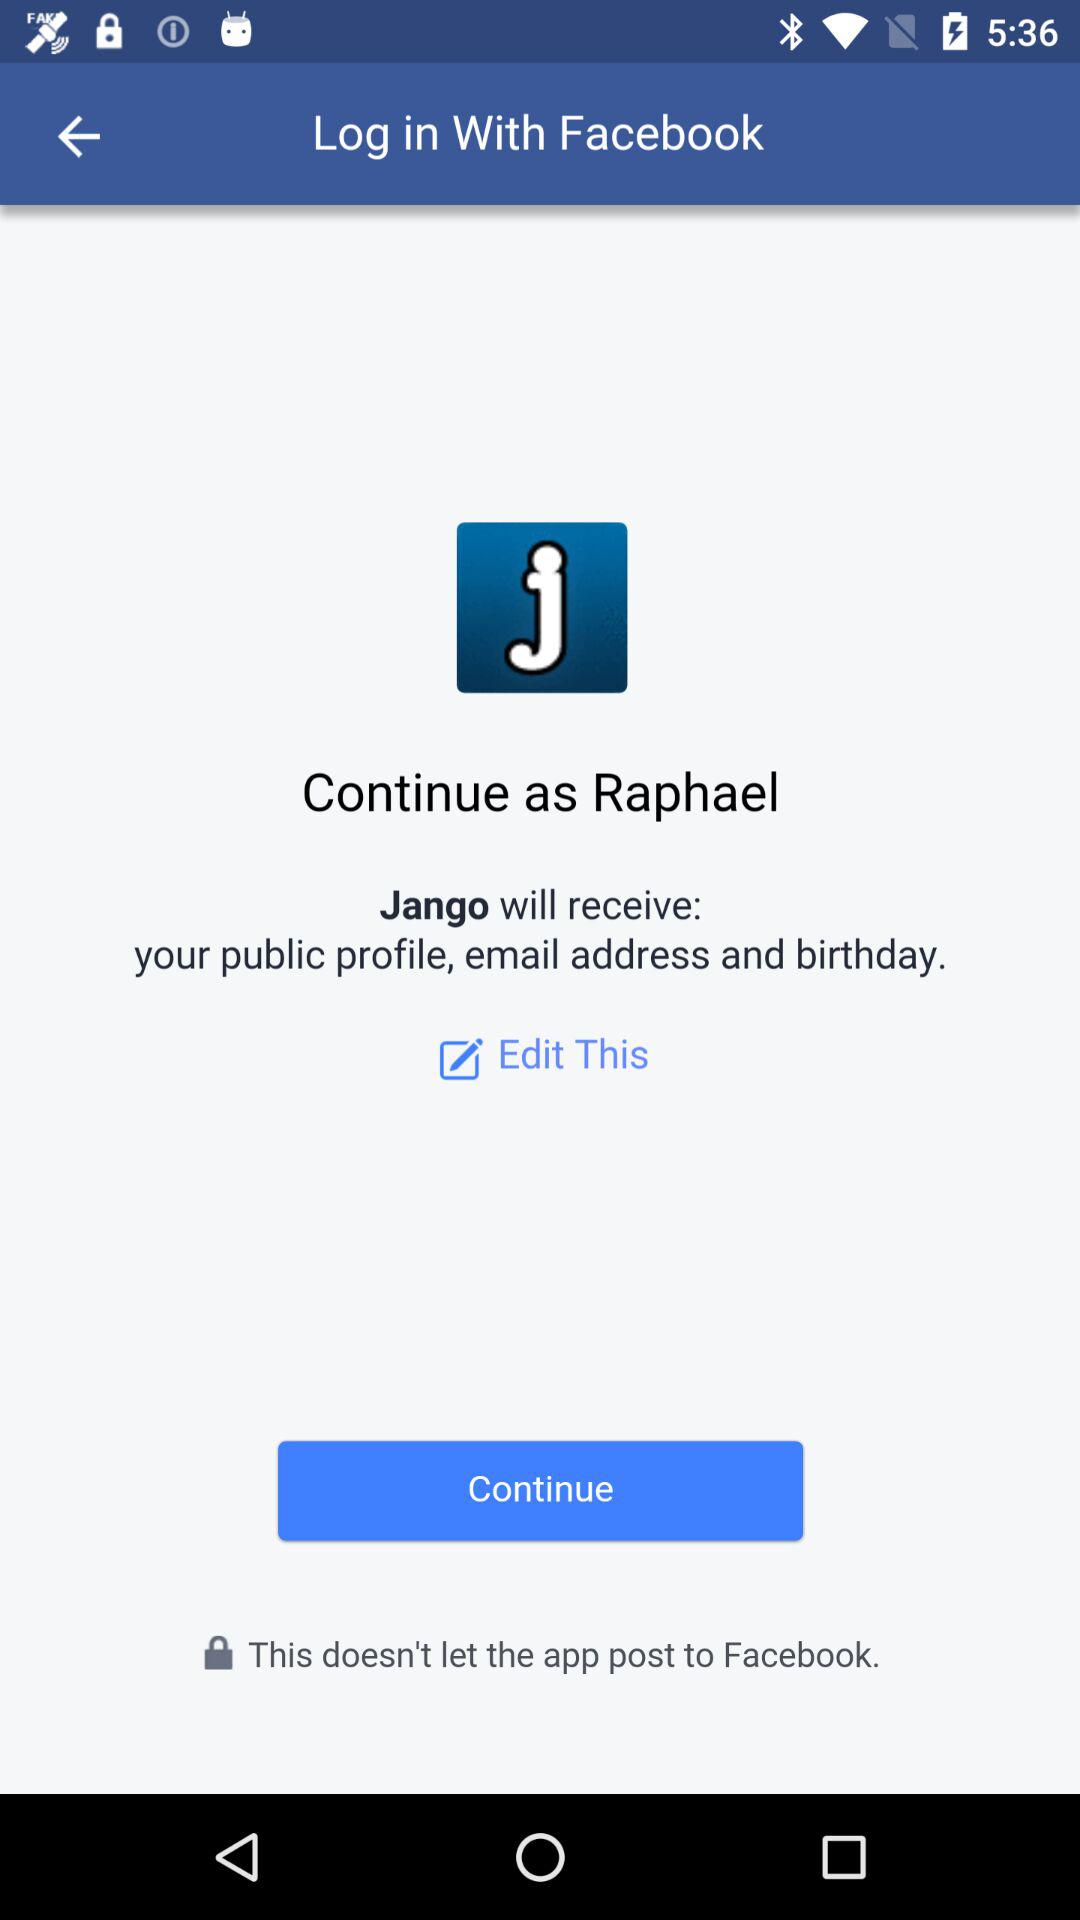Is there an option to modify the privacy settings before proceeding? Yes, there is an option to edit the information you provide. You can see the 'Edit This' link below the details about what information Jango will receive. 